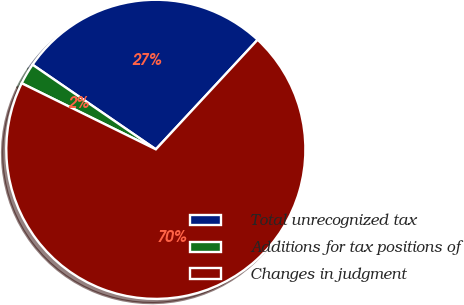Convert chart. <chart><loc_0><loc_0><loc_500><loc_500><pie_chart><fcel>Total unrecognized tax<fcel>Additions for tax positions of<fcel>Changes in judgment<nl><fcel>27.34%<fcel>2.29%<fcel>70.37%<nl></chart> 